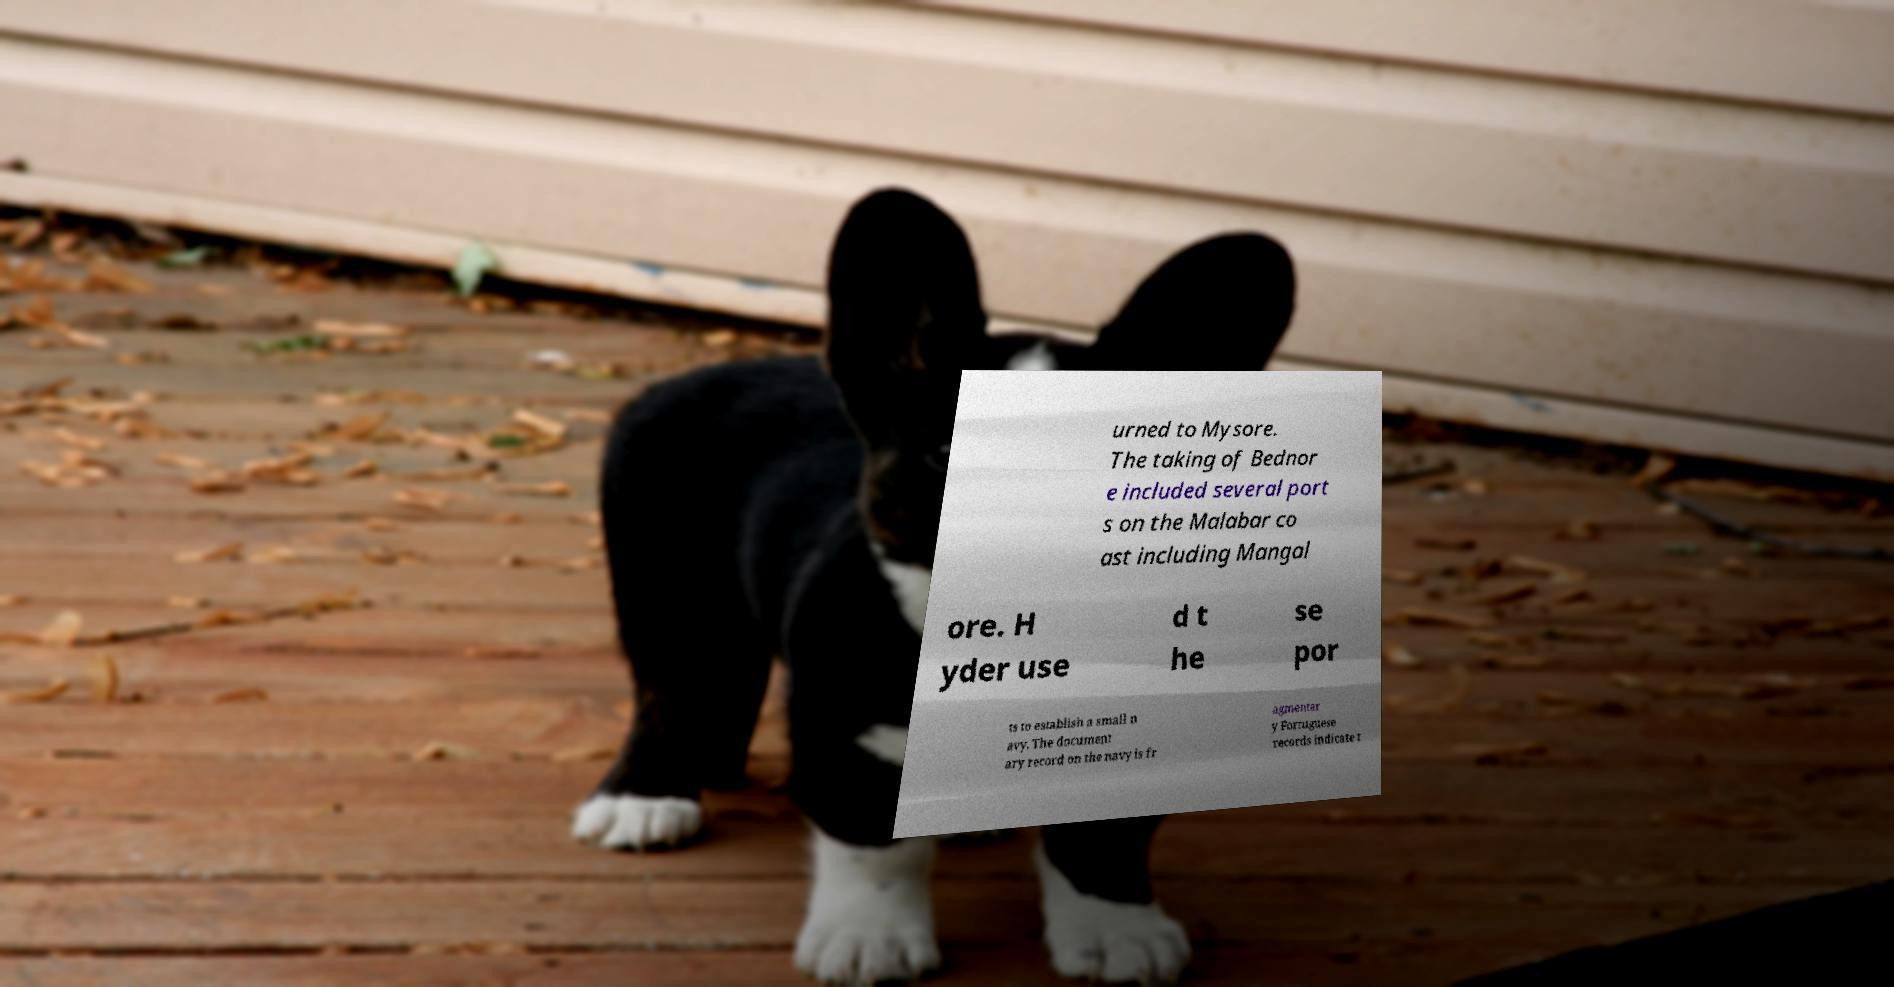There's text embedded in this image that I need extracted. Can you transcribe it verbatim? urned to Mysore. The taking of Bednor e included several port s on the Malabar co ast including Mangal ore. H yder use d t he se por ts to establish a small n avy. The document ary record on the navy is fr agmentar y Portuguese records indicate t 